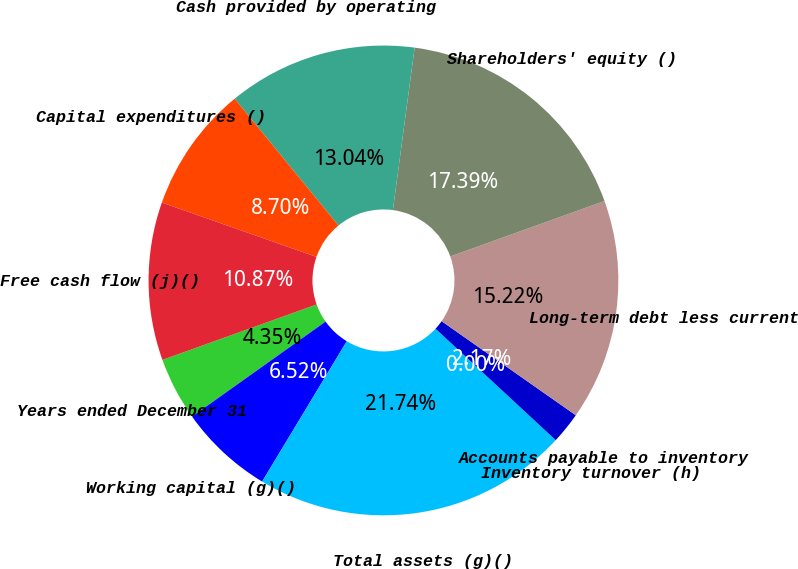Convert chart to OTSL. <chart><loc_0><loc_0><loc_500><loc_500><pie_chart><fcel>Years ended December 31<fcel>Working capital (g)()<fcel>Total assets (g)()<fcel>Inventory turnover (h)<fcel>Accounts payable to inventory<fcel>Long-term debt less current<fcel>Shareholders' equity ()<fcel>Cash provided by operating<fcel>Capital expenditures ()<fcel>Free cash flow (j)()<nl><fcel>4.35%<fcel>6.52%<fcel>21.74%<fcel>0.0%<fcel>2.17%<fcel>15.22%<fcel>17.39%<fcel>13.04%<fcel>8.7%<fcel>10.87%<nl></chart> 